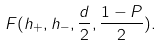<formula> <loc_0><loc_0><loc_500><loc_500>F ( h _ { + } , h _ { - } , \frac { d } { 2 } , \frac { 1 - P } { 2 } ) .</formula> 